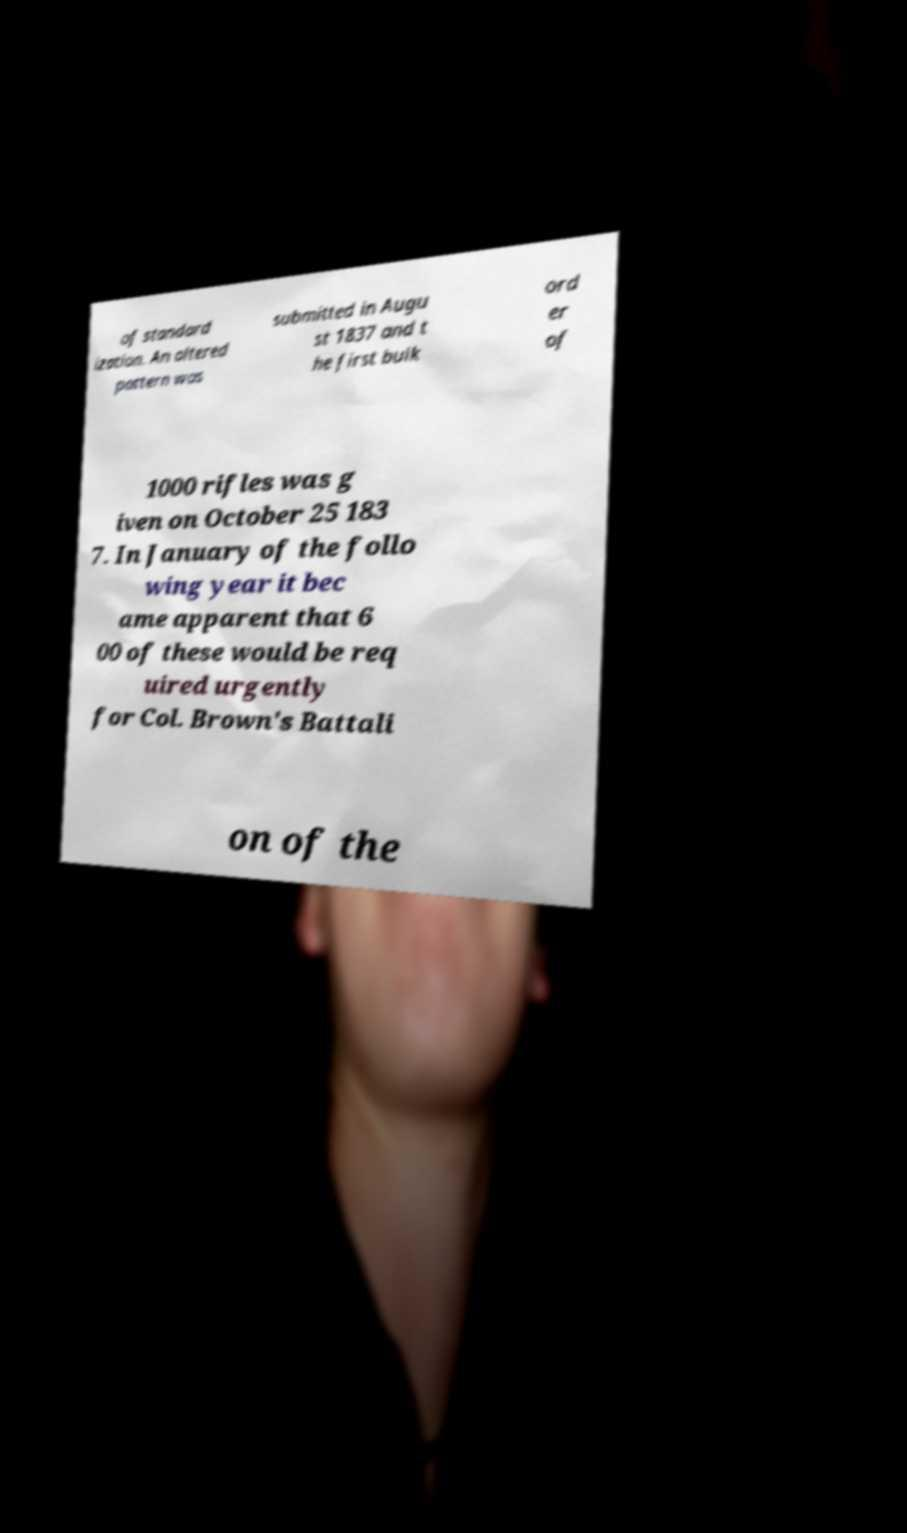For documentation purposes, I need the text within this image transcribed. Could you provide that? of standard ization. An altered pattern was submitted in Augu st 1837 and t he first bulk ord er of 1000 rifles was g iven on October 25 183 7. In January of the follo wing year it bec ame apparent that 6 00 of these would be req uired urgently for Col. Brown's Battali on of the 